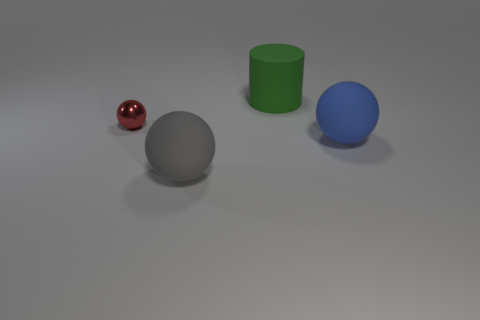Are there any other things that are the same size as the red shiny sphere?
Offer a very short reply. No. Do the large thing behind the large blue sphere and the big sphere to the right of the large gray rubber object have the same material?
Offer a very short reply. Yes. Is the number of big objects that are behind the small red metallic thing greater than the number of brown spheres?
Your answer should be very brief. Yes. There is a matte thing behind the rubber object on the right side of the cylinder; what is its color?
Offer a very short reply. Green. The green thing that is the same size as the gray sphere is what shape?
Offer a terse response. Cylinder. Are there an equal number of shiny objects that are behind the big cylinder and red metal things?
Your response must be concise. No. What is the material of the tiny thing behind the large sphere on the left side of the thing that is behind the tiny red metal object?
Your response must be concise. Metal. What is the shape of the big green object that is made of the same material as the large blue ball?
Offer a very short reply. Cylinder. Is there anything else that has the same color as the small metallic ball?
Offer a very short reply. No. What number of big rubber cylinders are to the left of the rubber sphere in front of the ball that is to the right of the gray ball?
Offer a terse response. 0. 